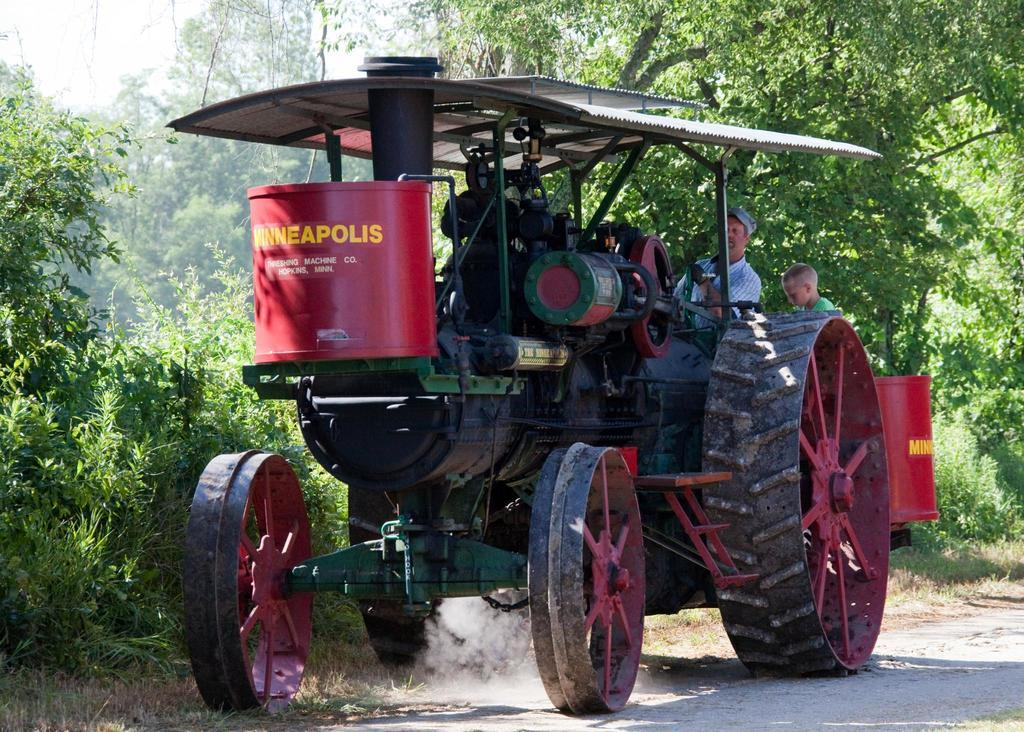How many people are in the image? There are two persons in the image. What is one person doing in the image? One person is driving a vehicle. Where is the vehicle located? The vehicle is on the road. What can be seen in the background of the image? There are trees and the sky visible in the background of the image. What type of hair is visible on the yoke in the image? There is no yoke or hair present in the image. Can you describe the color and texture of the sofa in the image? There is no sofa present in the image. 